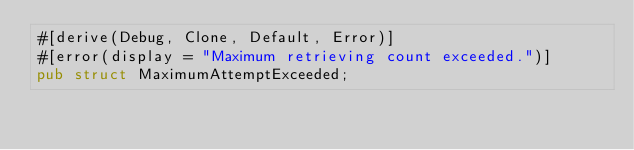<code> <loc_0><loc_0><loc_500><loc_500><_Rust_>#[derive(Debug, Clone, Default, Error)]
#[error(display = "Maximum retrieving count exceeded.")]
pub struct MaximumAttemptExceeded;
</code> 